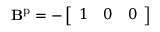<formula> <loc_0><loc_0><loc_500><loc_500>B ^ { p } = - \left [ \begin{array} { l l l } { 1 } & { 0 } & { 0 } \end{array} \right ]</formula> 